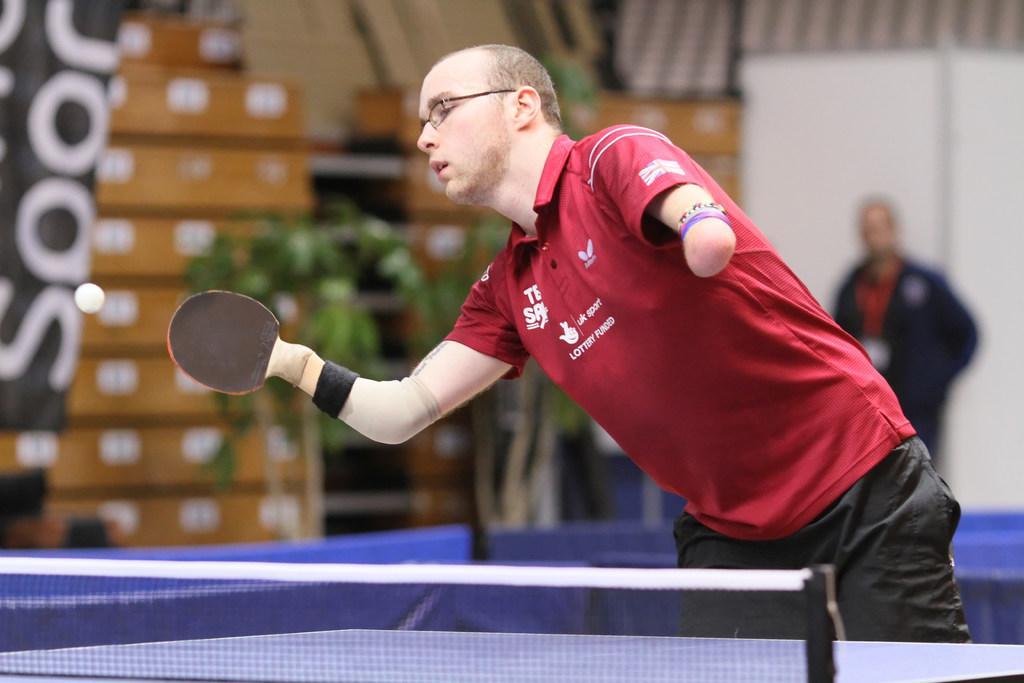What is the main subject of the image? There is a person in the image. What is the person doing in the image? The person is standing and holding a table tennis bat. What object is related to the activity the person is engaged in? There is a table tennis table in the image. Can you describe the background of the image? The background of the image is blurred. How many zebras can be seen playing table tennis in the image? There are no zebras present in the image, and therefore no such activity can be observed. 